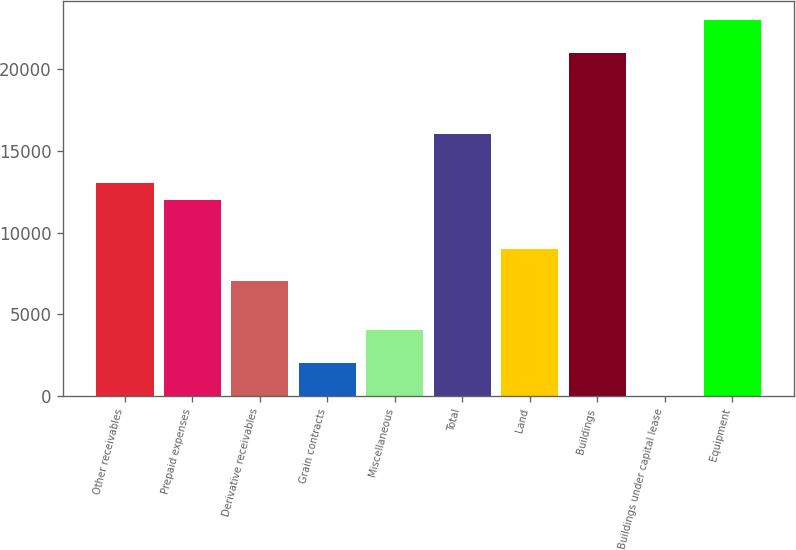Convert chart. <chart><loc_0><loc_0><loc_500><loc_500><bar_chart><fcel>Other receivables<fcel>Prepaid expenses<fcel>Derivative receivables<fcel>Grain contracts<fcel>Miscellaneous<fcel>Total<fcel>Land<fcel>Buildings<fcel>Buildings under capital lease<fcel>Equipment<nl><fcel>13004.1<fcel>12003.8<fcel>7002.33<fcel>2000.88<fcel>4001.46<fcel>16004.9<fcel>9002.91<fcel>21006.4<fcel>0.3<fcel>23007<nl></chart> 